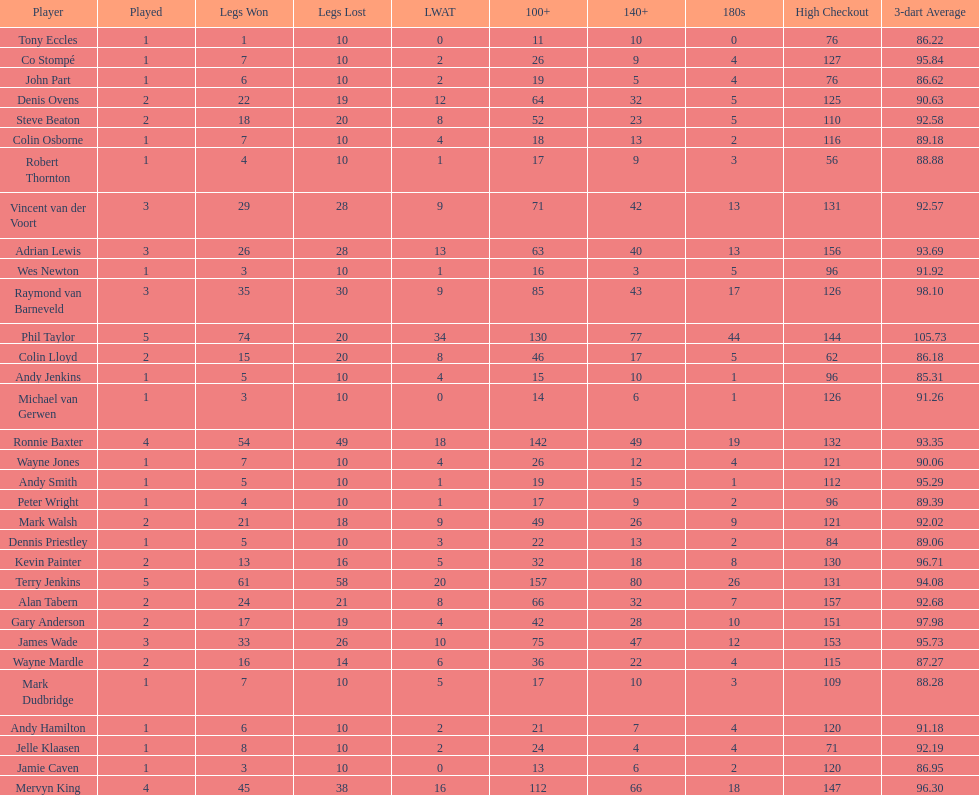Can you parse all the data within this table? {'header': ['Player', 'Played', 'Legs Won', 'Legs Lost', 'LWAT', '100+', '140+', '180s', 'High Checkout', '3-dart Average'], 'rows': [['Tony Eccles', '1', '1', '10', '0', '11', '10', '0', '76', '86.22'], ['Co Stompé', '1', '7', '10', '2', '26', '9', '4', '127', '95.84'], ['John Part', '1', '6', '10', '2', '19', '5', '4', '76', '86.62'], ['Denis Ovens', '2', '22', '19', '12', '64', '32', '5', '125', '90.63'], ['Steve Beaton', '2', '18', '20', '8', '52', '23', '5', '110', '92.58'], ['Colin Osborne', '1', '7', '10', '4', '18', '13', '2', '116', '89.18'], ['Robert Thornton', '1', '4', '10', '1', '17', '9', '3', '56', '88.88'], ['Vincent van der Voort', '3', '29', '28', '9', '71', '42', '13', '131', '92.57'], ['Adrian Lewis', '3', '26', '28', '13', '63', '40', '13', '156', '93.69'], ['Wes Newton', '1', '3', '10', '1', '16', '3', '5', '96', '91.92'], ['Raymond van Barneveld', '3', '35', '30', '9', '85', '43', '17', '126', '98.10'], ['Phil Taylor', '5', '74', '20', '34', '130', '77', '44', '144', '105.73'], ['Colin Lloyd', '2', '15', '20', '8', '46', '17', '5', '62', '86.18'], ['Andy Jenkins', '1', '5', '10', '4', '15', '10', '1', '96', '85.31'], ['Michael van Gerwen', '1', '3', '10', '0', '14', '6', '1', '126', '91.26'], ['Ronnie Baxter', '4', '54', '49', '18', '142', '49', '19', '132', '93.35'], ['Wayne Jones', '1', '7', '10', '4', '26', '12', '4', '121', '90.06'], ['Andy Smith', '1', '5', '10', '1', '19', '15', '1', '112', '95.29'], ['Peter Wright', '1', '4', '10', '1', '17', '9', '2', '96', '89.39'], ['Mark Walsh', '2', '21', '18', '9', '49', '26', '9', '121', '92.02'], ['Dennis Priestley', '1', '5', '10', '3', '22', '13', '2', '84', '89.06'], ['Kevin Painter', '2', '13', '16', '5', '32', '18', '8', '130', '96.71'], ['Terry Jenkins', '5', '61', '58', '20', '157', '80', '26', '131', '94.08'], ['Alan Tabern', '2', '24', '21', '8', '66', '32', '7', '157', '92.68'], ['Gary Anderson', '2', '17', '19', '4', '42', '28', '10', '151', '97.98'], ['James Wade', '3', '33', '26', '10', '75', '47', '12', '153', '95.73'], ['Wayne Mardle', '2', '16', '14', '6', '36', '22', '4', '115', '87.27'], ['Mark Dudbridge', '1', '7', '10', '5', '17', '10', '3', '109', '88.28'], ['Andy Hamilton', '1', '6', '10', '2', '21', '7', '4', '120', '91.18'], ['Jelle Klaasen', '1', '8', '10', '2', '24', '4', '4', '71', '92.19'], ['Jamie Caven', '1', '3', '10', '0', '13', '6', '2', '120', '86.95'], ['Mervyn King', '4', '45', '38', '16', '112', '66', '18', '147', '96.30']]} Was andy smith or kevin painter's 3-dart average 96.71? Kevin Painter. 